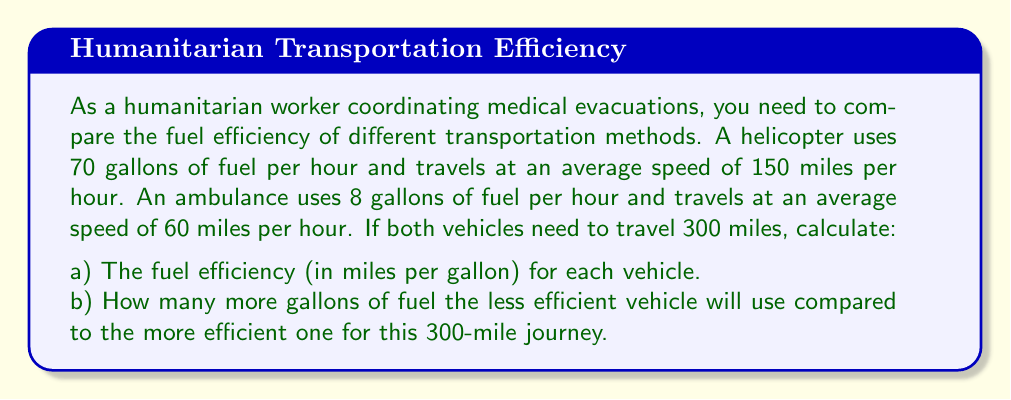Can you answer this question? Let's approach this problem step by step:

a) To calculate fuel efficiency, we need to find miles traveled per gallon of fuel used.

For the helicopter:
1. Time to travel 300 miles: $t_h = \frac{300 \text{ miles}}{150 \text{ miles/hour}} = 2 \text{ hours}$
2. Fuel used: $f_h = 70 \text{ gallons/hour} \times 2 \text{ hours} = 140 \text{ gallons}$
3. Fuel efficiency: $e_h = \frac{300 \text{ miles}}{140 \text{ gallons}} = 2.14 \text{ miles/gallon}$

For the ambulance:
1. Time to travel 300 miles: $t_a = \frac{300 \text{ miles}}{60 \text{ miles/hour}} = 5 \text{ hours}$
2. Fuel used: $f_a = 8 \text{ gallons/hour} \times 5 \text{ hours} = 40 \text{ gallons}$
3. Fuel efficiency: $e_a = \frac{300 \text{ miles}}{40 \text{ gallons}} = 7.5 \text{ miles/gallon}$

b) To compare fuel usage:
1. The helicopter is less efficient, using 140 gallons.
2. The ambulance is more efficient, using 40 gallons.
3. Difference in fuel usage: $140 \text{ gallons} - 40 \text{ gallons} = 100 \text{ gallons}$
Answer: a) Helicopter fuel efficiency: 2.14 miles/gallon
   Ambulance fuel efficiency: 7.5 miles/gallon

b) The helicopter (less efficient vehicle) will use 100 gallons more fuel than the ambulance for the 300-mile journey. 